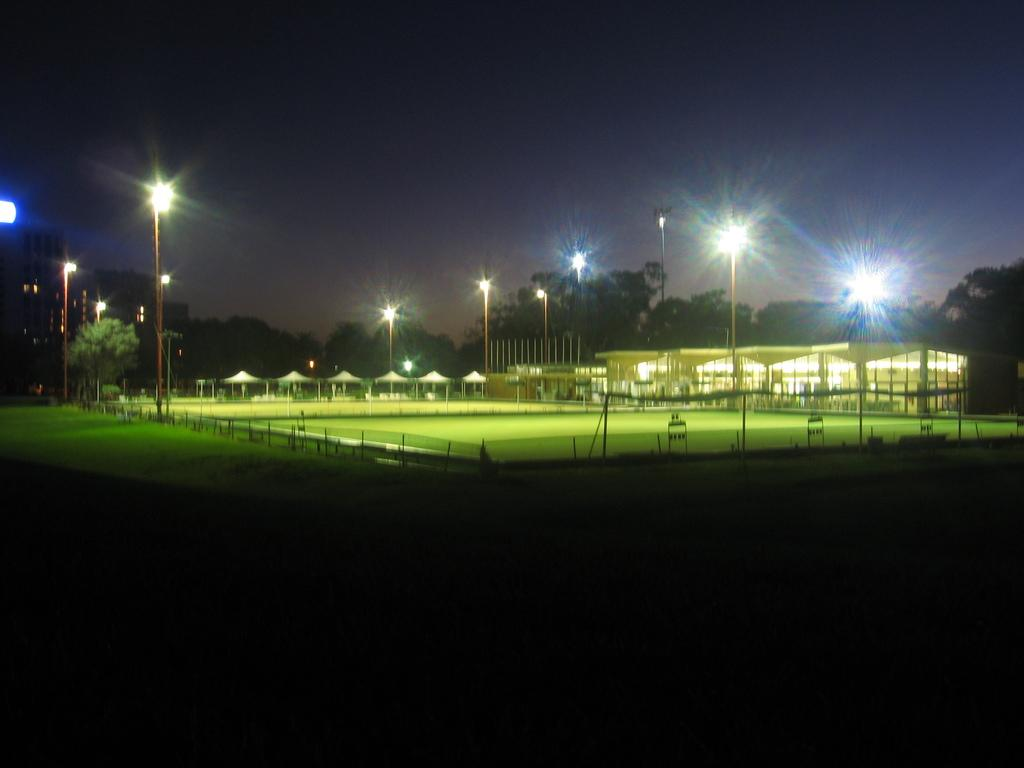What type of structures can be seen in the image? There are buildings and tents in the image. What other objects are present in the image? There are poles and lights visible in the image. What can be seen in the background of the image? There are trees and the sky visible in the background of the image. How many snails can be seen climbing on the table in the image? There are no snails or tables present in the image. What type of hook is used to hang the lights in the image? There is no hook visible in the image; the lights are attached to poles. 